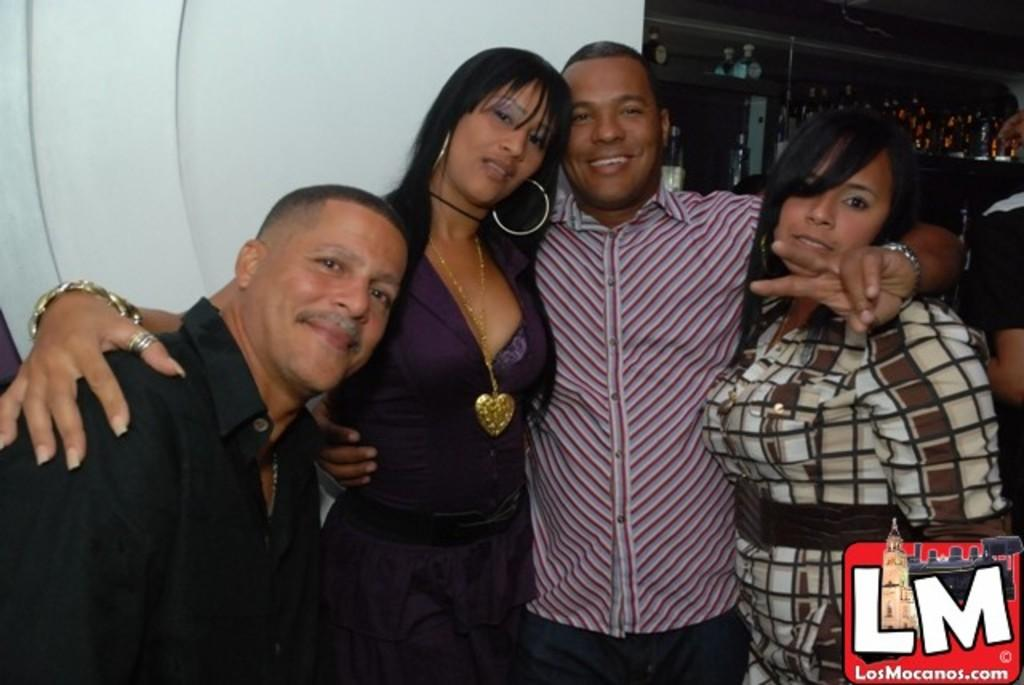How many people are present in the image? There are four persons in the image. What can be seen inside the cupboard in the image? There are glass bottles and other objects in the cupboard. What is visible in the background of the image? There is a wall in the background of the image. Is there any indication of the image's origin or ownership? Yes, there is a watermark on the image. What type of land is visible in the image? There is no land visible in the image; it features four persons and a cupboard with objects. How does the loss of the grandfather affect the people in the image? There is no indication of a grandfather or any loss in the image; it only shows four persons and a cupboard with objects. 